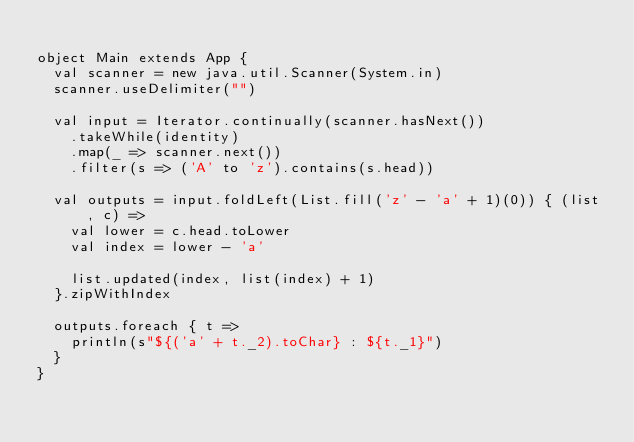<code> <loc_0><loc_0><loc_500><loc_500><_Scala_>
object Main extends App {
  val scanner = new java.util.Scanner(System.in)
  scanner.useDelimiter("")

  val input = Iterator.continually(scanner.hasNext())
    .takeWhile(identity)
    .map(_ => scanner.next())
    .filter(s => ('A' to 'z').contains(s.head))

  val outputs = input.foldLeft(List.fill('z' - 'a' + 1)(0)) { (list, c) =>
    val lower = c.head.toLower
    val index = lower - 'a'

    list.updated(index, list(index) + 1)
  }.zipWithIndex

  outputs.foreach { t =>
    println(s"${('a' + t._2).toChar} : ${t._1}")
  }
}</code> 